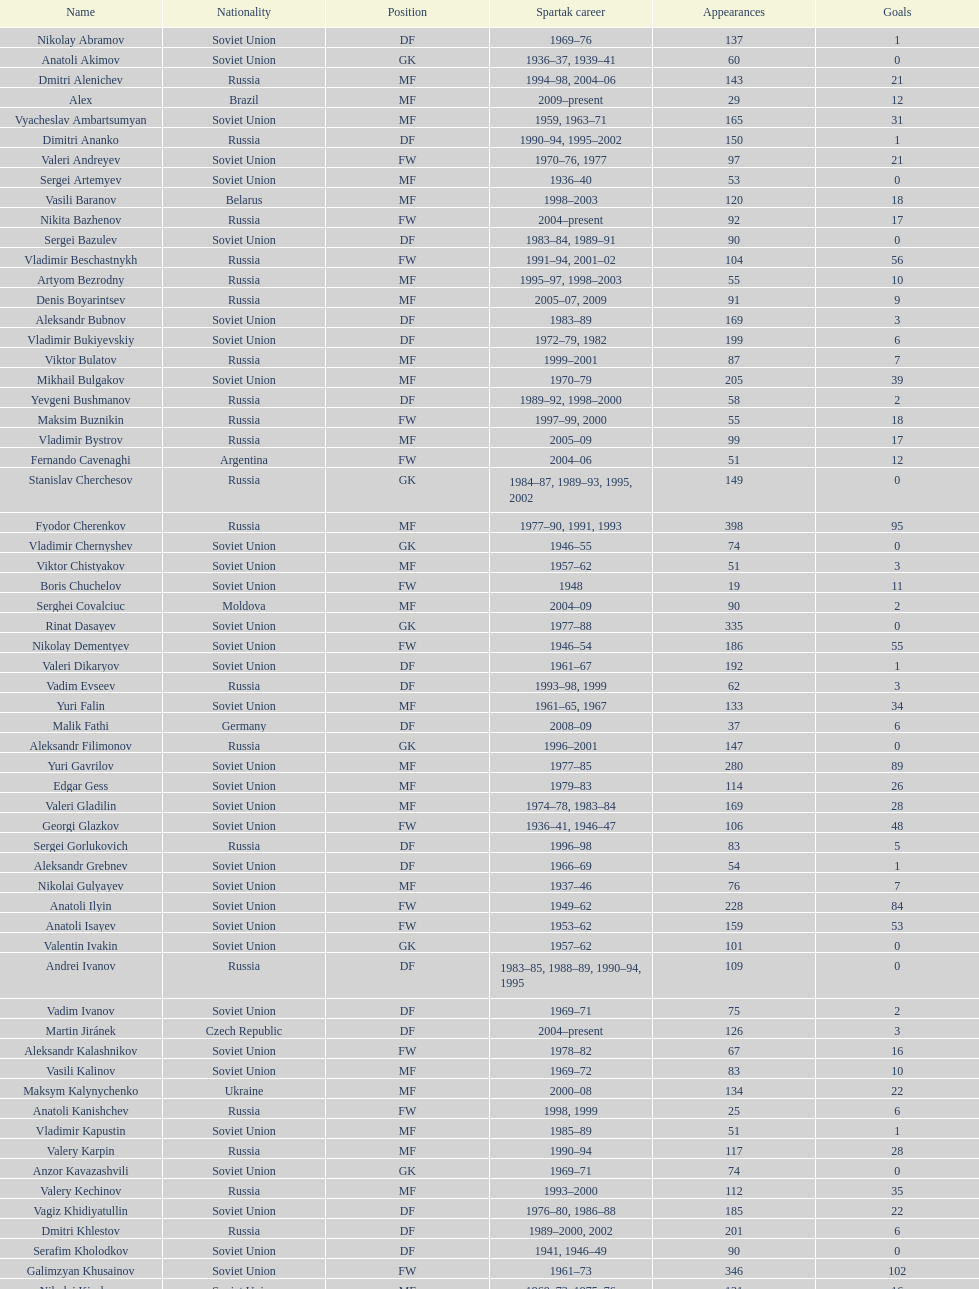Who had the highest number of appearances? Fyodor Cherenkov. 